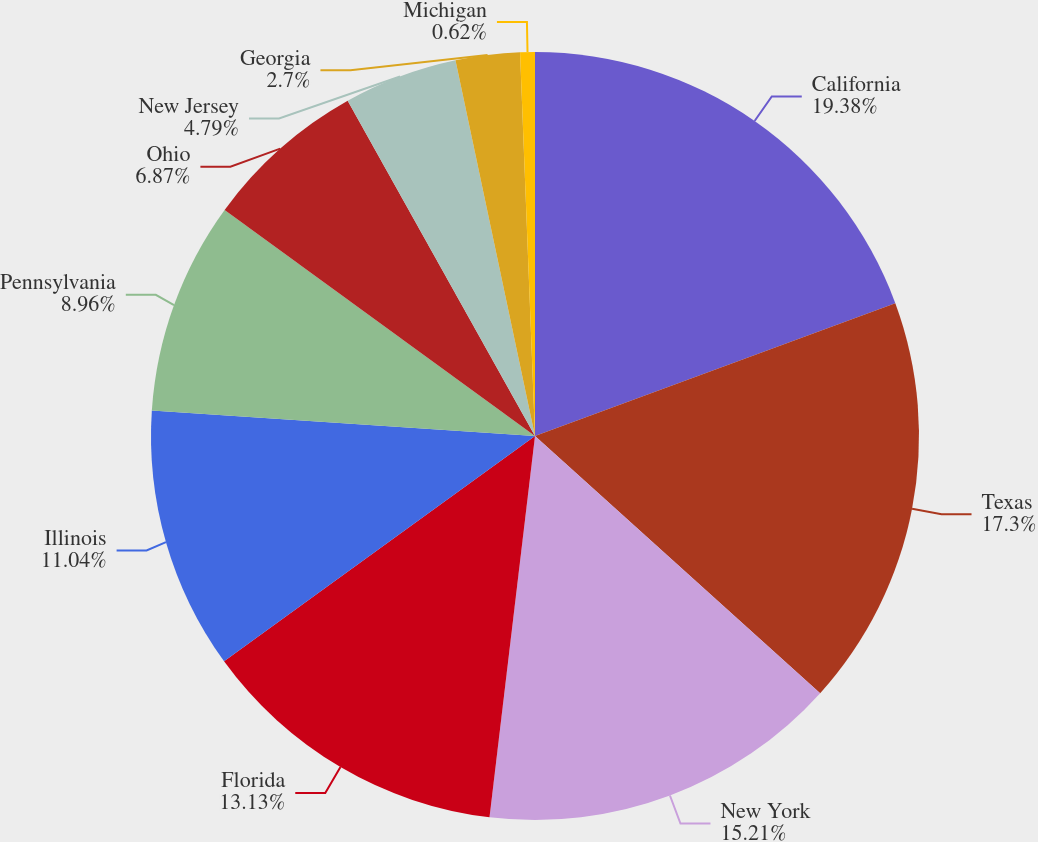Convert chart to OTSL. <chart><loc_0><loc_0><loc_500><loc_500><pie_chart><fcel>California<fcel>Texas<fcel>New York<fcel>Florida<fcel>Illinois<fcel>Pennsylvania<fcel>Ohio<fcel>New Jersey<fcel>Georgia<fcel>Michigan<nl><fcel>19.38%<fcel>17.3%<fcel>15.21%<fcel>13.13%<fcel>11.04%<fcel>8.96%<fcel>6.87%<fcel>4.79%<fcel>2.7%<fcel>0.62%<nl></chart> 